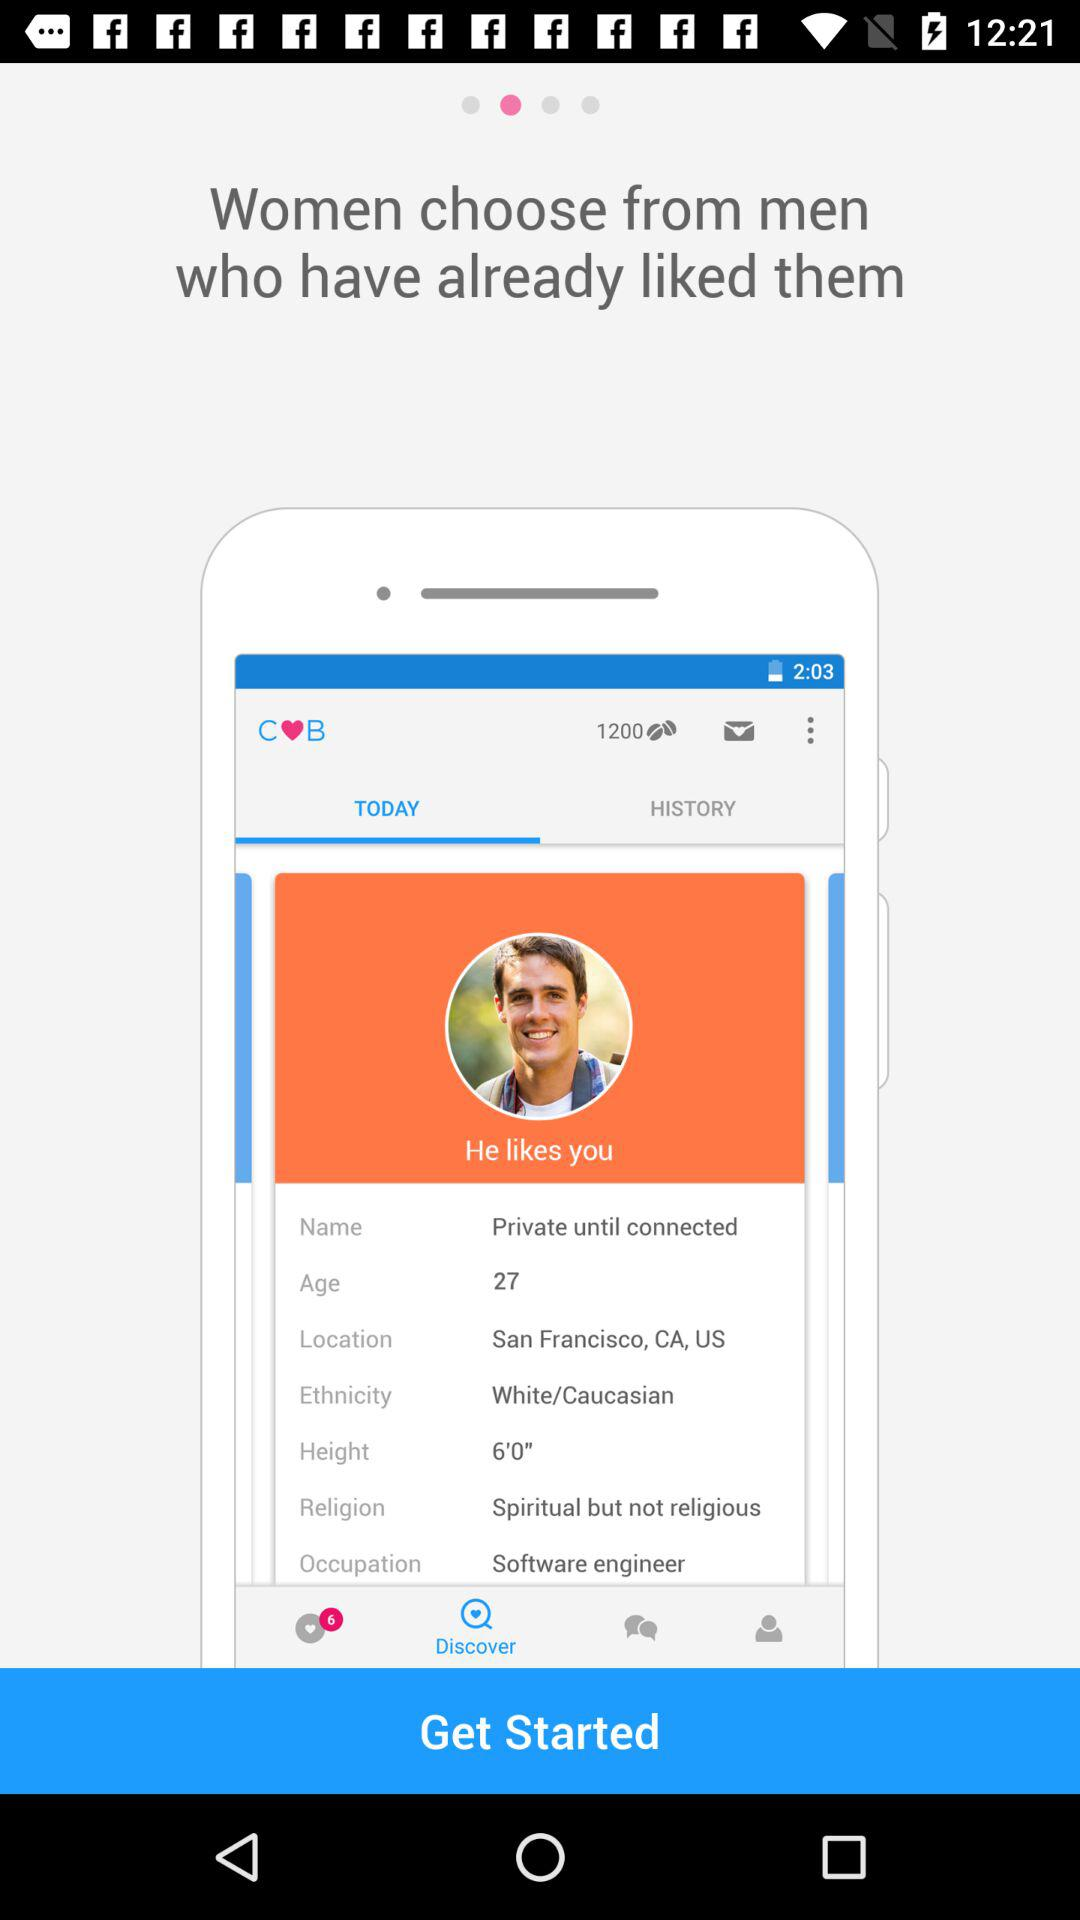What is the occupation of the man? The occupation is software engineer. 